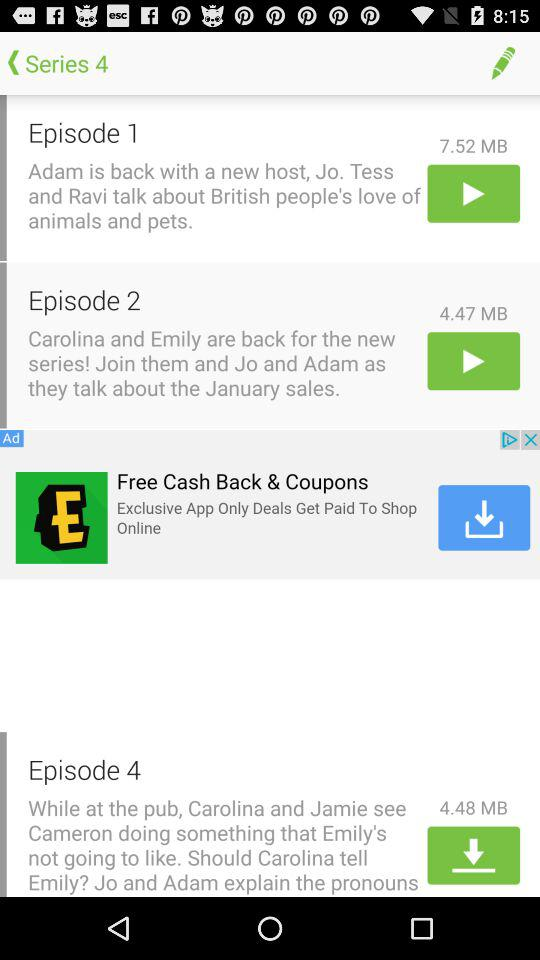Which series is it? It is series 4. 